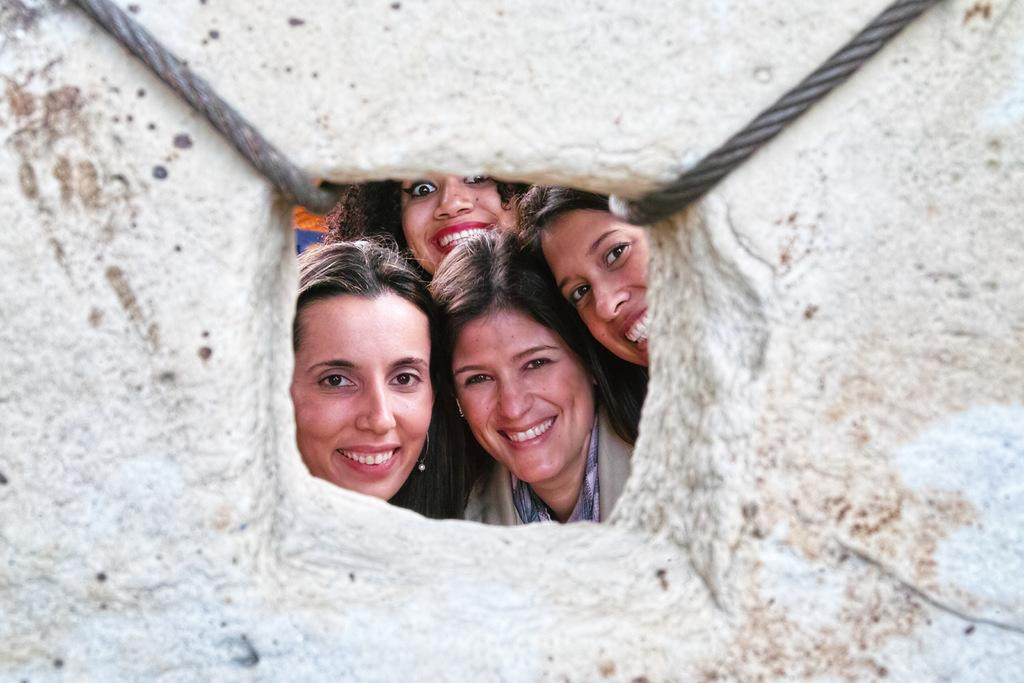What object can be seen in the image that is made of a hard material? There is a stone in the image that is made of a hard material. What type of material is used to create the ropes in the image? The ropes in the image are made of a flexible material. How many women are present in the background of the image? There are four women in the background of the image. What expression do the women have in the image? The women are smiling in the image. What type of yarn is the kitten using to knit a scarf in the image? There is no kitten or yarn present in the image; it only features a stone, ropes, and four women. 